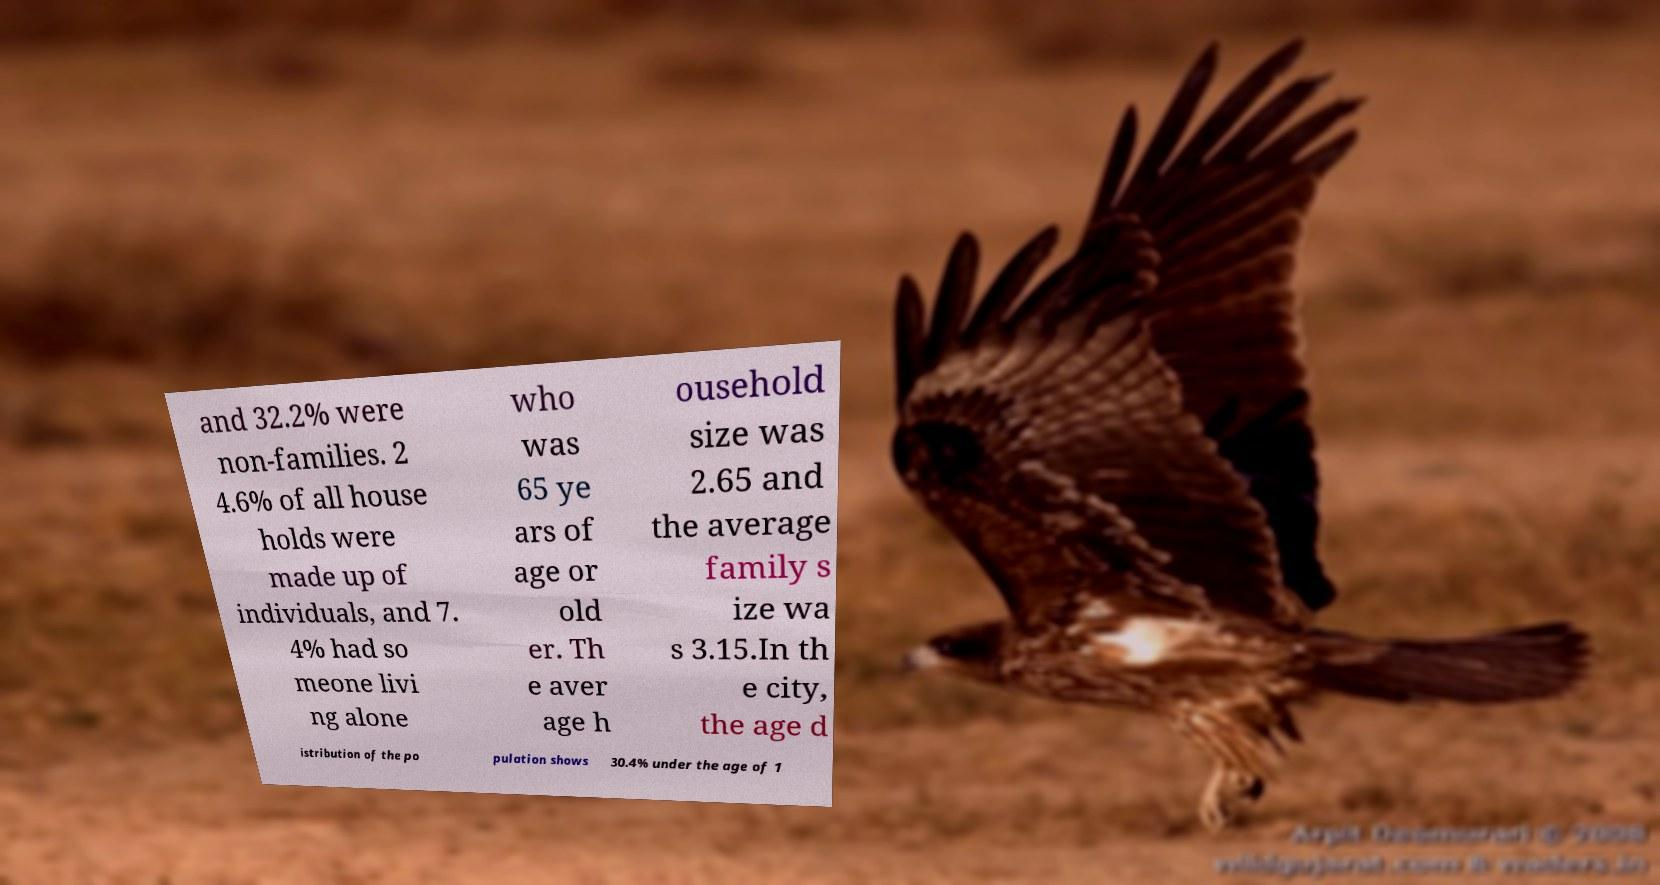What messages or text are displayed in this image? I need them in a readable, typed format. and 32.2% were non-families. 2 4.6% of all house holds were made up of individuals, and 7. 4% had so meone livi ng alone who was 65 ye ars of age or old er. Th e aver age h ousehold size was 2.65 and the average family s ize wa s 3.15.In th e city, the age d istribution of the po pulation shows 30.4% under the age of 1 